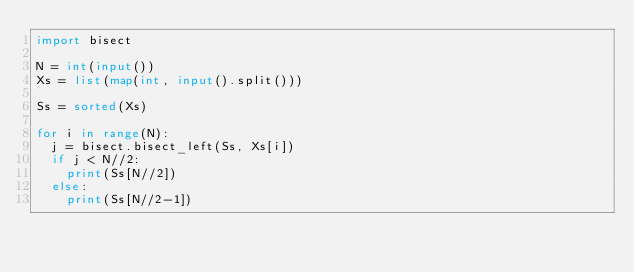<code> <loc_0><loc_0><loc_500><loc_500><_Python_>import bisect

N = int(input())
Xs = list(map(int, input().split()))

Ss = sorted(Xs)

for i in range(N):
  j = bisect.bisect_left(Ss, Xs[i])
  if j < N//2:
    print(Ss[N//2])
  else:
    print(Ss[N//2-1])</code> 